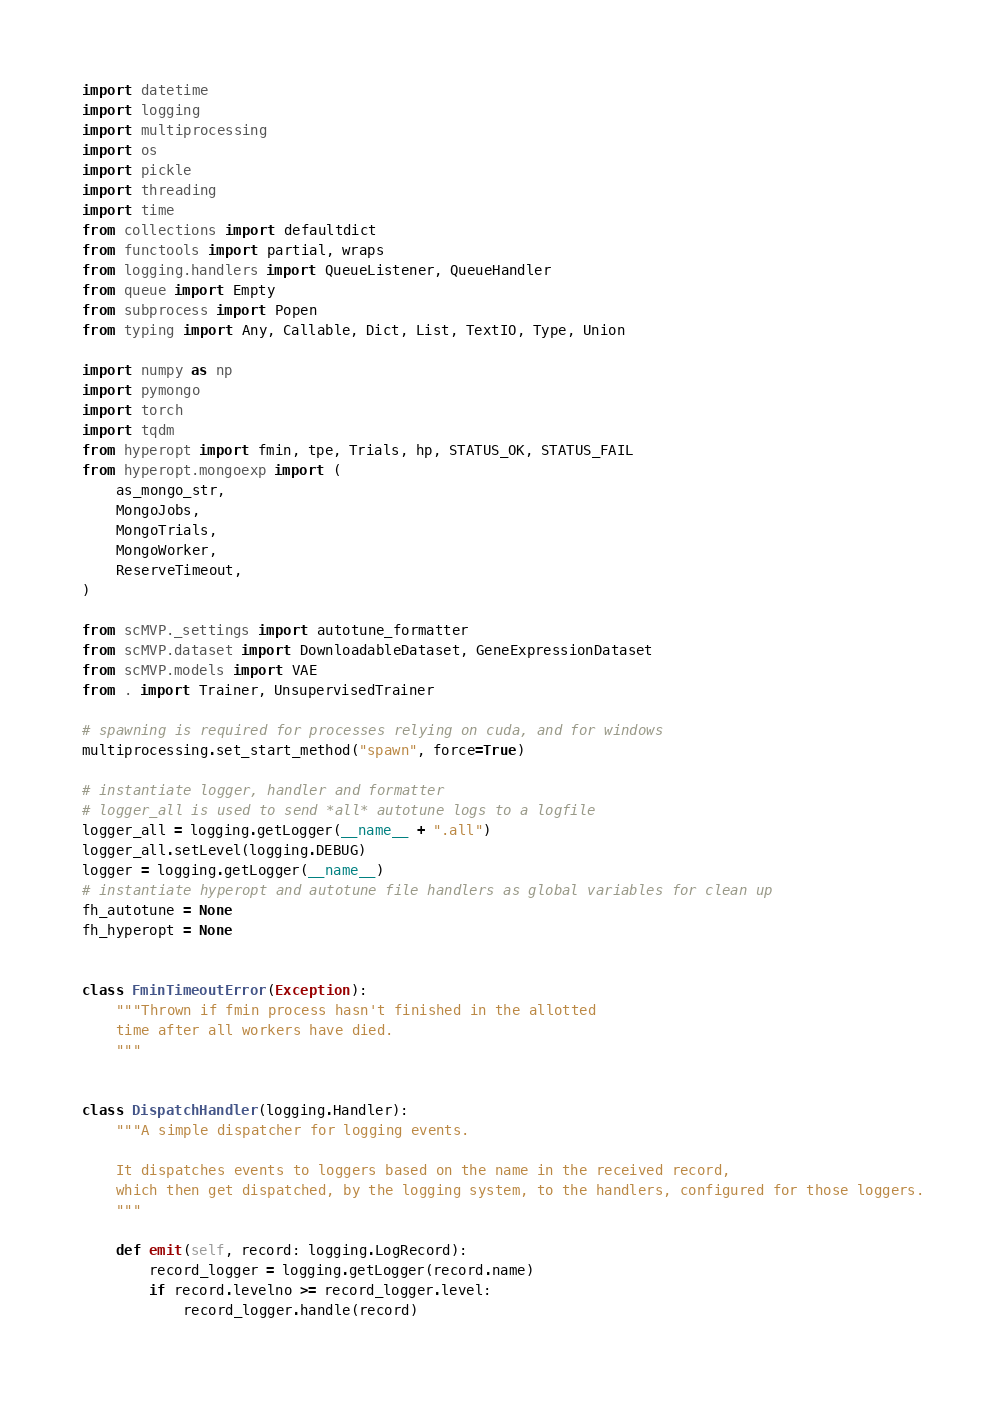<code> <loc_0><loc_0><loc_500><loc_500><_Python_>import datetime
import logging
import multiprocessing
import os
import pickle
import threading
import time
from collections import defaultdict
from functools import partial, wraps
from logging.handlers import QueueListener, QueueHandler
from queue import Empty
from subprocess import Popen
from typing import Any, Callable, Dict, List, TextIO, Type, Union

import numpy as np
import pymongo
import torch
import tqdm
from hyperopt import fmin, tpe, Trials, hp, STATUS_OK, STATUS_FAIL
from hyperopt.mongoexp import (
    as_mongo_str,
    MongoJobs,
    MongoTrials,
    MongoWorker,
    ReserveTimeout,
)

from scMVP._settings import autotune_formatter
from scMVP.dataset import DownloadableDataset, GeneExpressionDataset
from scMVP.models import VAE
from . import Trainer, UnsupervisedTrainer

# spawning is required for processes relying on cuda, and for windows
multiprocessing.set_start_method("spawn", force=True)

# instantiate logger, handler and formatter
# logger_all is used to send *all* autotune logs to a logfile
logger_all = logging.getLogger(__name__ + ".all")
logger_all.setLevel(logging.DEBUG)
logger = logging.getLogger(__name__)
# instantiate hyperopt and autotune file handlers as global variables for clean up
fh_autotune = None
fh_hyperopt = None


class FminTimeoutError(Exception):
    """Thrown if fmin process hasn't finished in the allotted
    time after all workers have died.
    """


class DispatchHandler(logging.Handler):
    """A simple dispatcher for logging events.

    It dispatches events to loggers based on the name in the received record,
    which then get dispatched, by the logging system, to the handlers, configured for those loggers.
    """

    def emit(self, record: logging.LogRecord):
        record_logger = logging.getLogger(record.name)
        if record.levelno >= record_logger.level:
            record_logger.handle(record)

</code> 